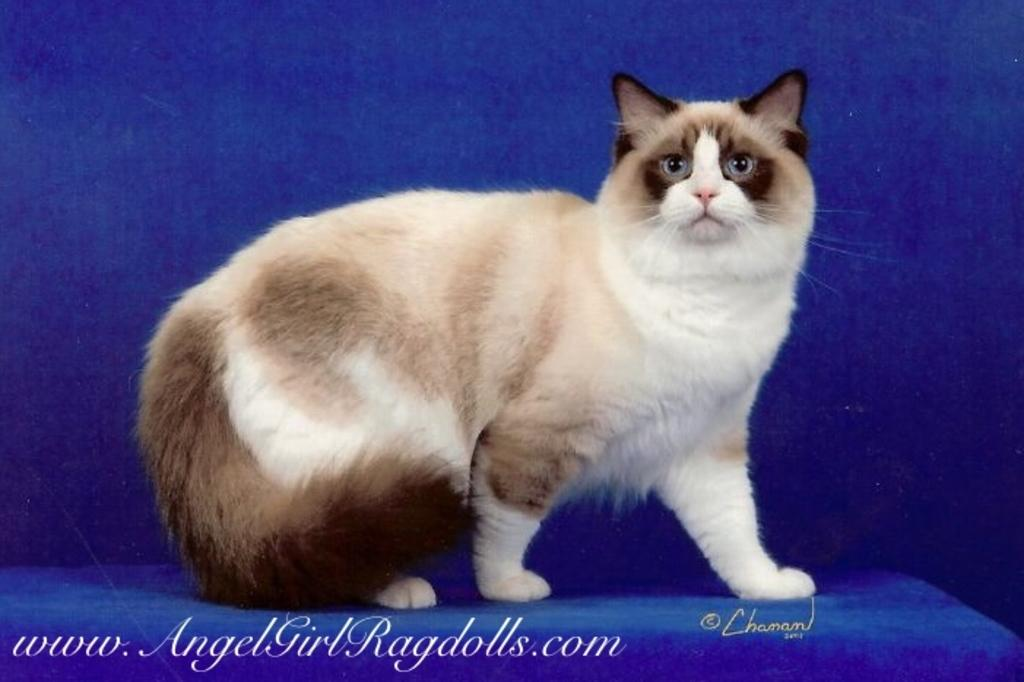What type of animal is in the image? There is a cat in the image. Is there any text associated with the cat? Yes, there is text on the cat. What color is the background of the image? The background of the image is blue. What type of caption is the cat providing for the air in the image? There is no caption or air present in the image; it features a cat with text on it and a blue background. 